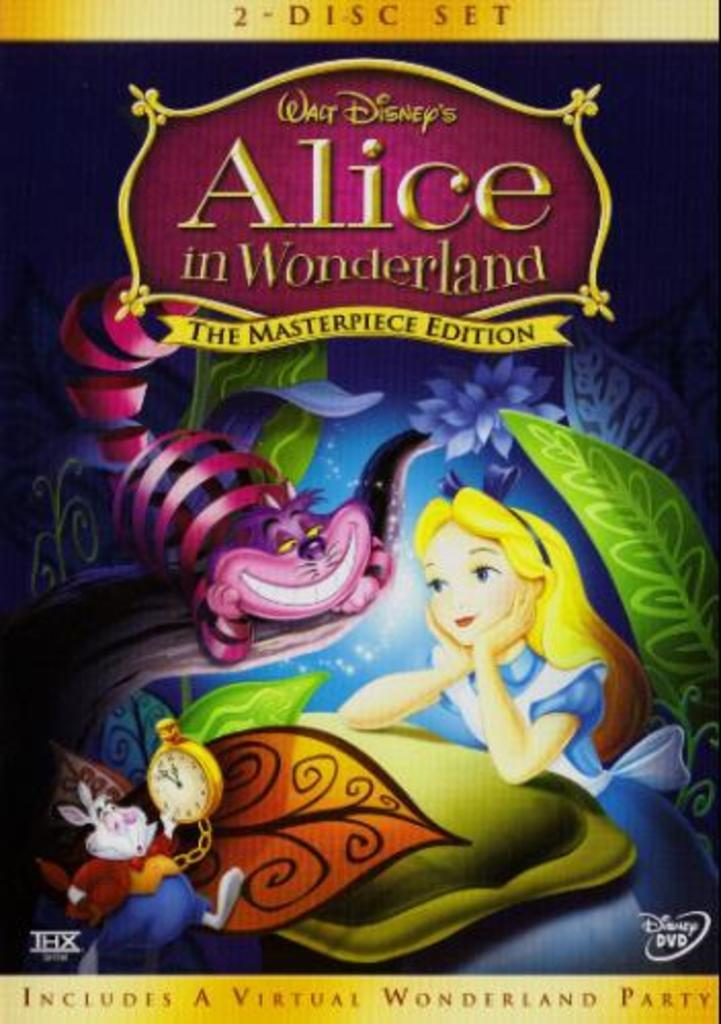<image>
Present a compact description of the photo's key features. The front cover of a DVD case for Alice in Wonderland. 